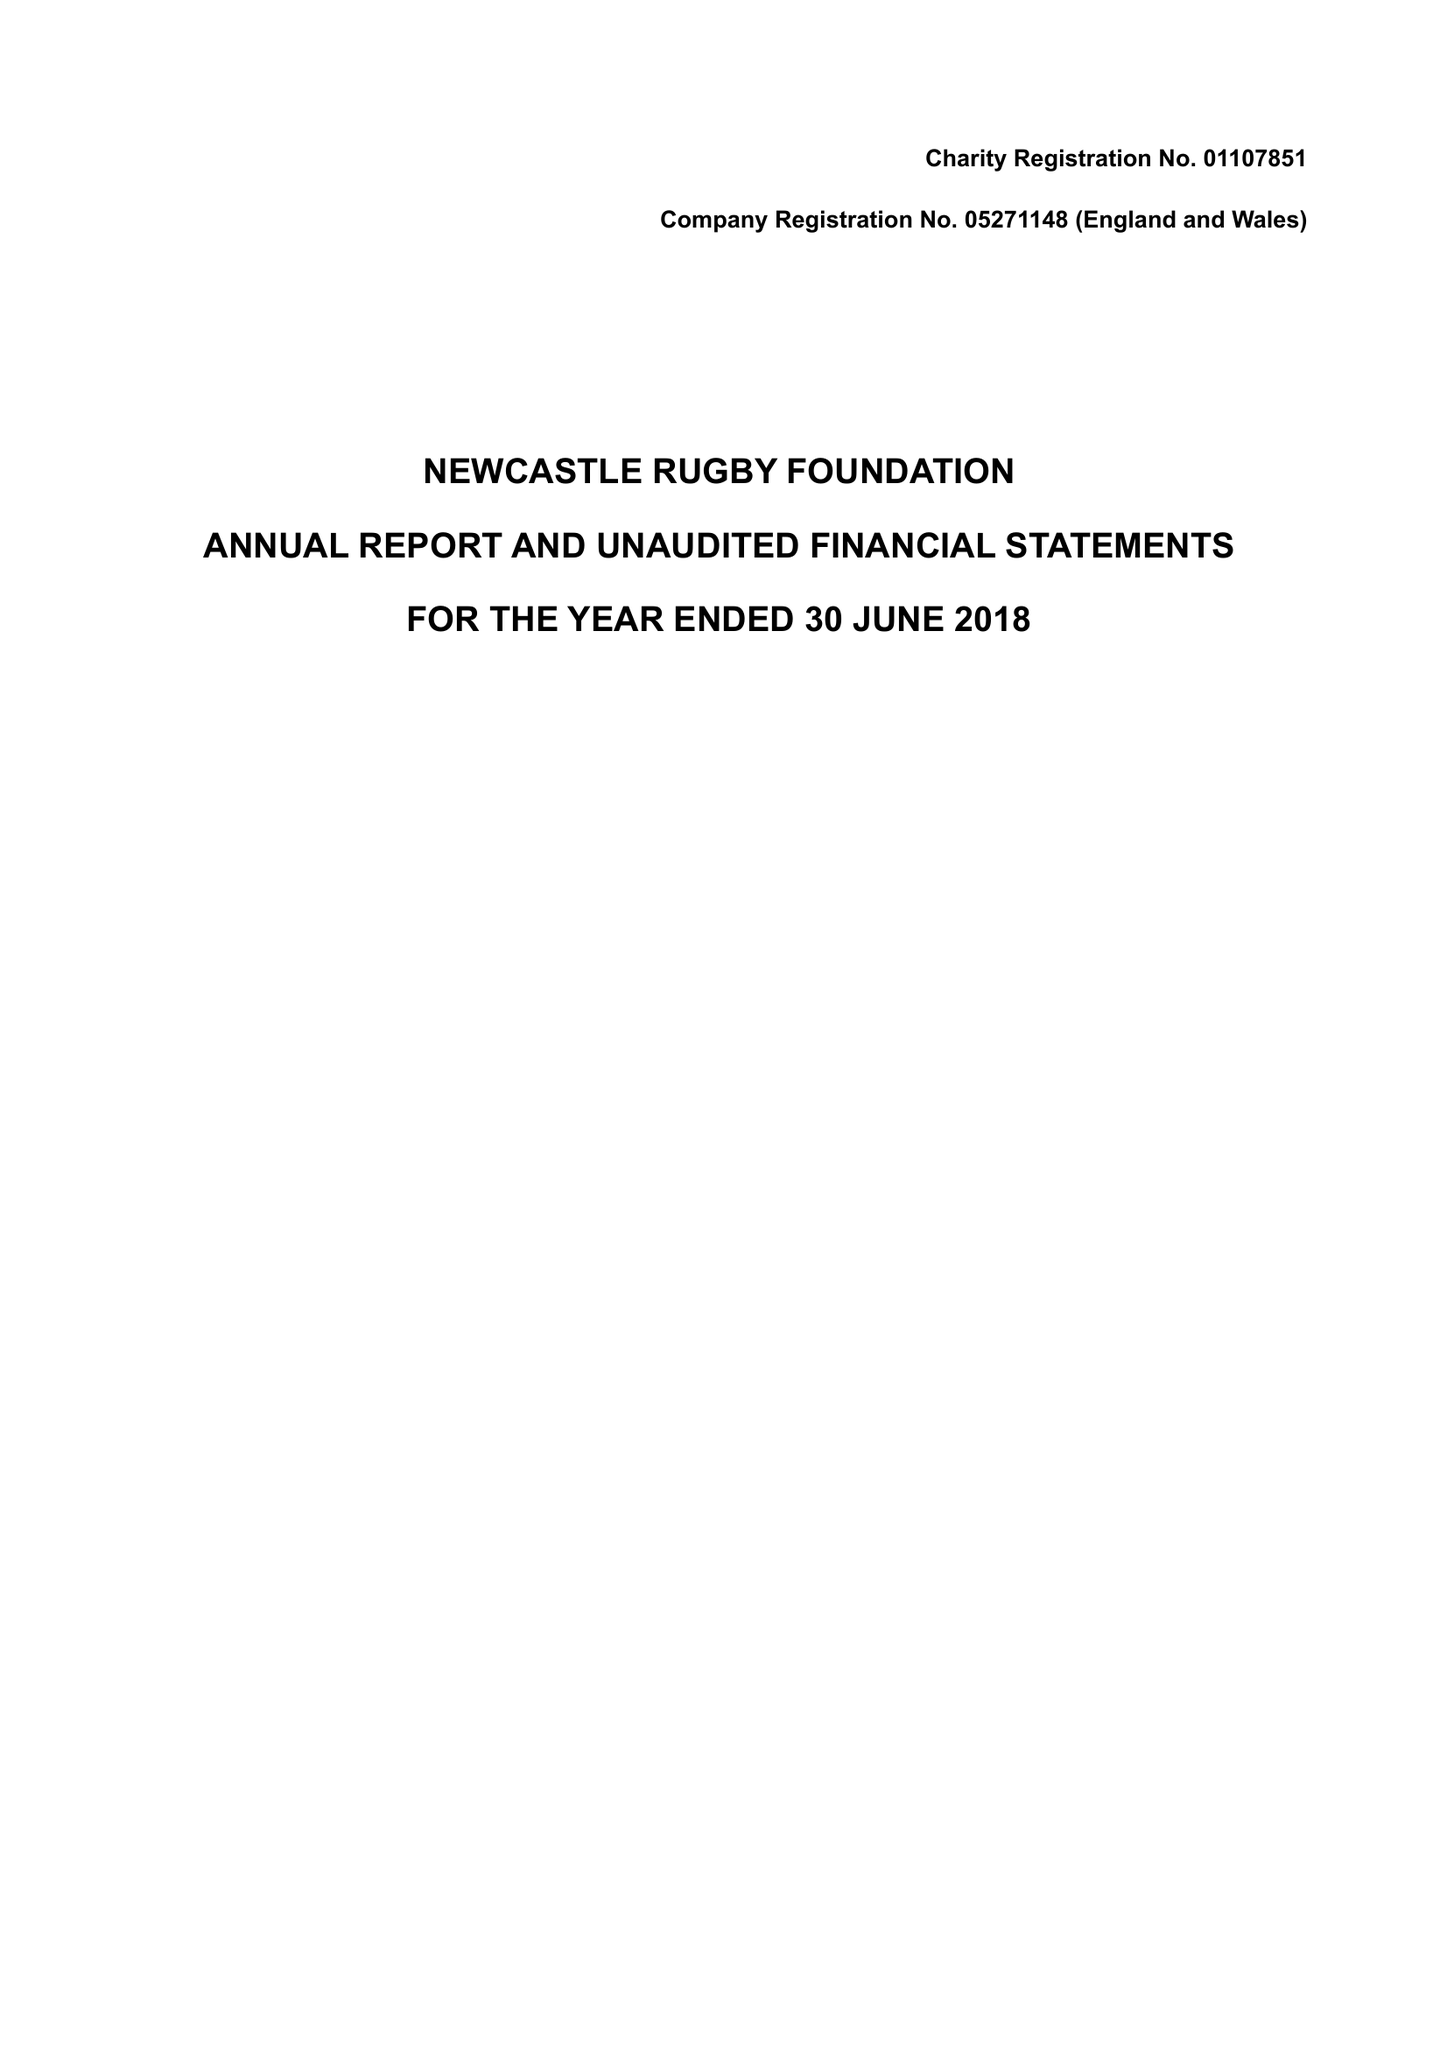What is the value for the income_annually_in_british_pounds?
Answer the question using a single word or phrase. 472893.00 